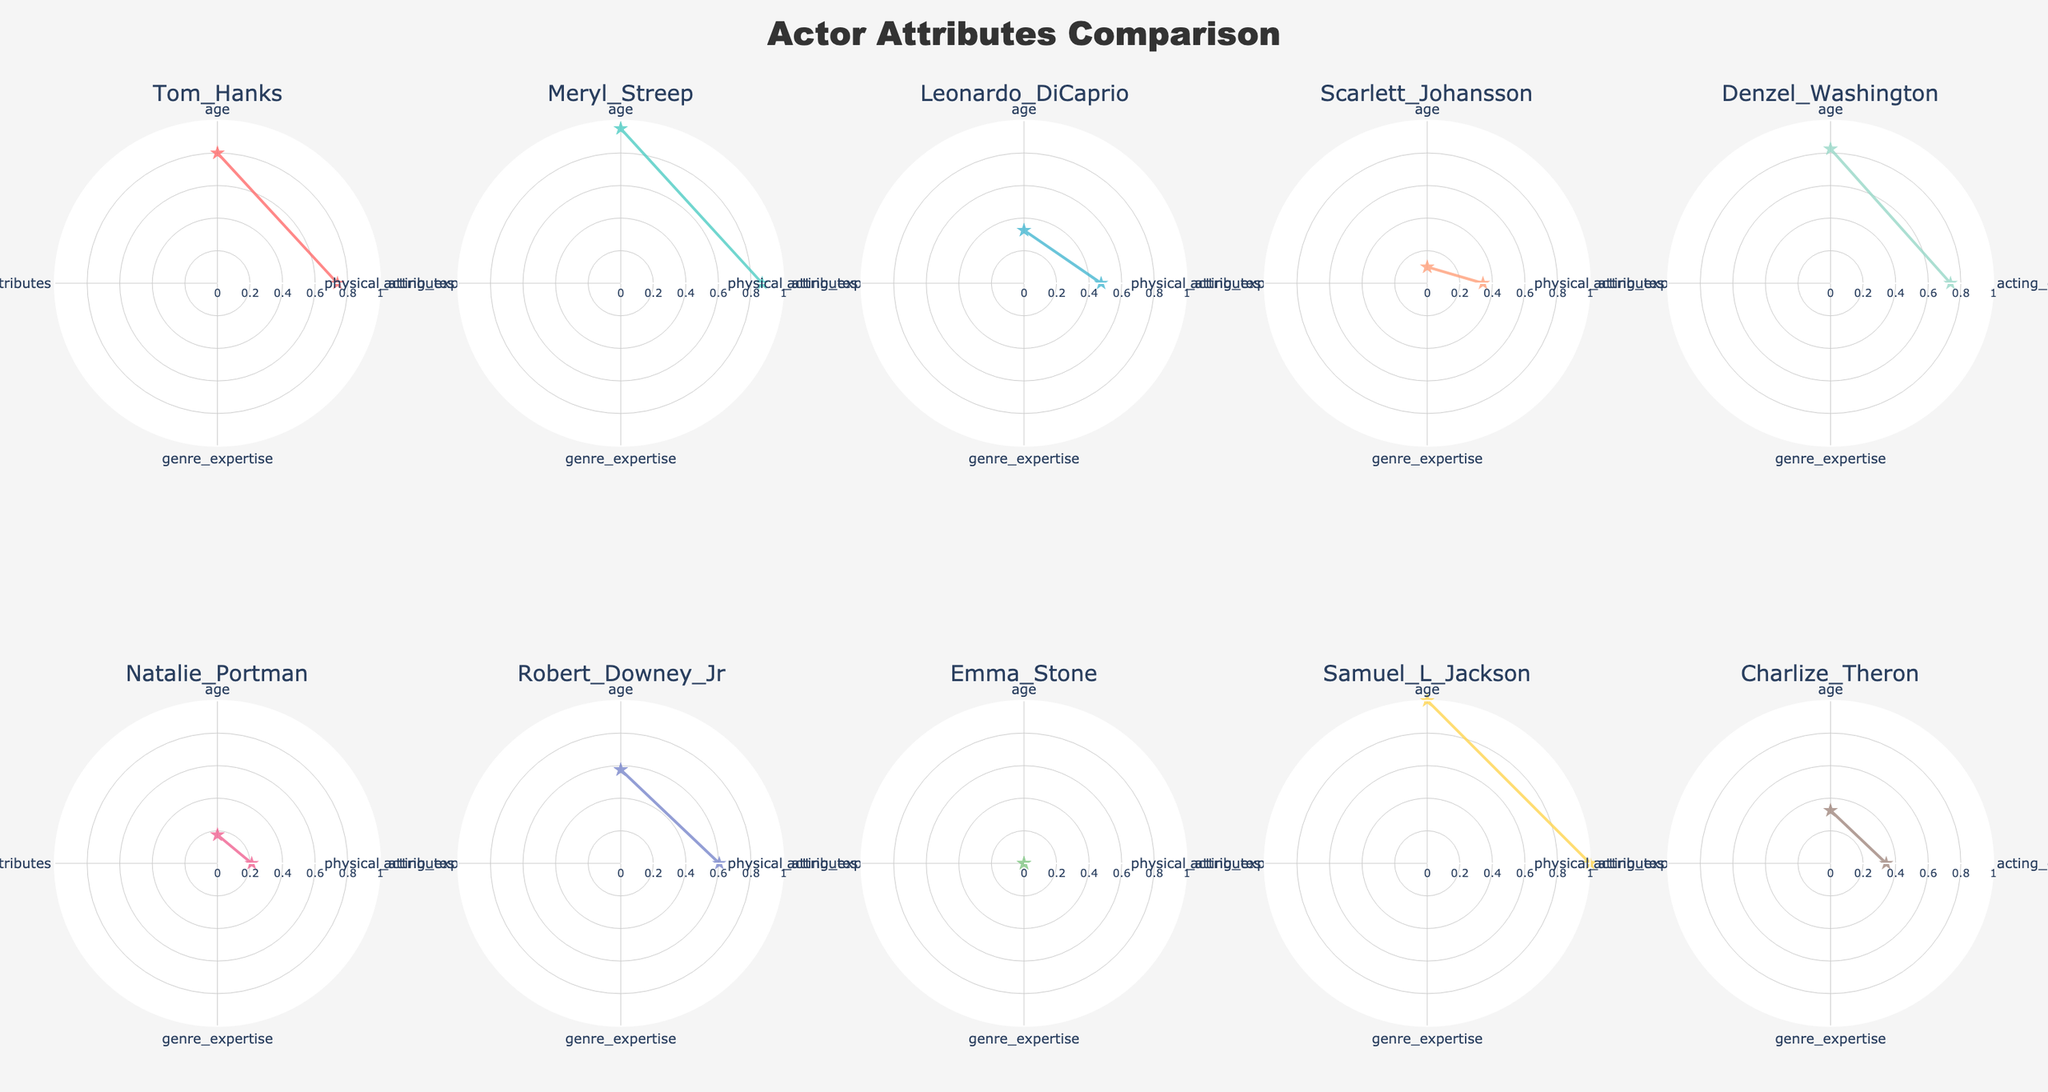What's the title of the figure? The title is usually displayed at the top of the plot. By observing the area above the plots, we can see it.
Answer: Actor Attributes Comparison Which actor has the highest value for acting experience? Look for the subplot that shows the highest radial value for acting experience. Since Samuel L. Jackson has been active for 50 years, he will have the highest value.
Answer: Samuel L. Jackson Who has the least genre expertise among all actors? Identify the subplot with the smallest radial extent for genre expertise. This actor has fewer genres listed. Natalie Portman has 3 genres, which is the lowest.
Answer: Natalie Portman What attributes are used for the radar chart? The attributes are the key points connected by lines in each subplot. By reading the radial axis labels, we see the attributes are age, acting experience, genre expertise, and physical attributes.
Answer: Age, Acting Experience, Genre Expertise, Physical Attributes Which female actor has the highest number of physical attributes? Compare the subplots of female actors (Meryl Streep, Scarlett Johansson, Natalie Portman, Emma Stone, Charlize Theron) to see who has the most extended physical attributes values.
Answer: Charlize Theron How does Tom Hanks' acting experience compare to Scarlett Johansson's? Examine both Tom Hanks and Scarlett Johansson’s subplots. Identify and compare the radial lengths corresponding to acting experience. Tom Hanks has 40 years, while Scarlett Johansson has 25 years.
Answer: Tom Hanks has more acting experience than Scarlett Johansson Out of Meryl Streep and Denzel Washington, who has more expertise in genres? Look at the genre expertise of both actors in their subplots. Count the number of genres listed if needed. Both are known for multiple genres, but Denzel Washington's radial length might be slightly greater.
Answer: Denzel Washington Which attribute varies the most among all actors? Observe the radar plots to see which attribute shows the most considerable differences in radial lengths. Acting experience shows significant variation, from 12 years to 50 years.
Answer: Acting Experience Which actor has both high age and high acting experience normalized values? Look for an actor with long radial lengths in both age and acting experience dimensions. Samuel L. Jackson, aged 72 with 50 years of experience, fits these criteria.
Answer: Samuel L. Jackson 